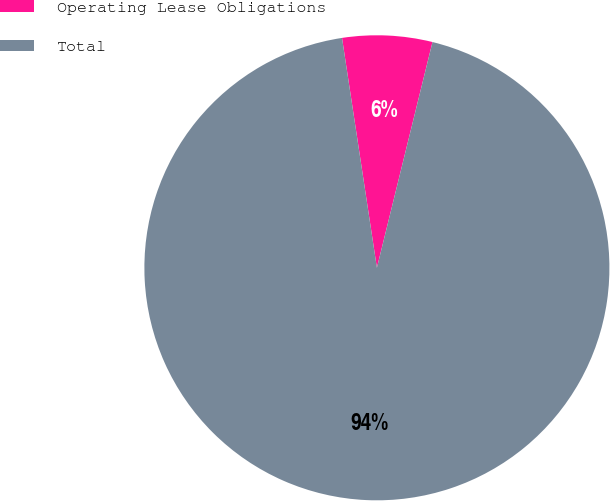Convert chart to OTSL. <chart><loc_0><loc_0><loc_500><loc_500><pie_chart><fcel>Operating Lease Obligations<fcel>Total<nl><fcel>6.24%<fcel>93.76%<nl></chart> 